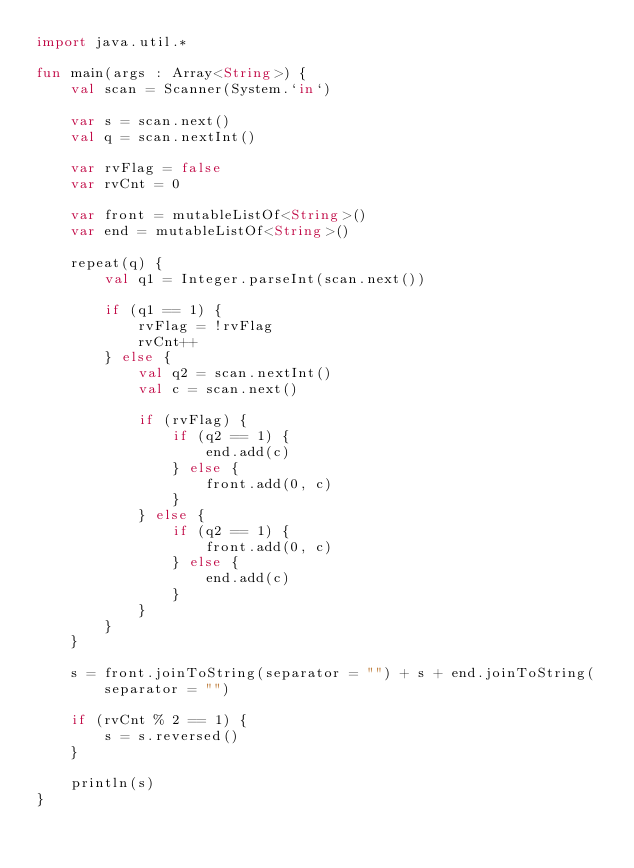<code> <loc_0><loc_0><loc_500><loc_500><_Kotlin_>import java.util.*

fun main(args : Array<String>) {
    val scan = Scanner(System.`in`)

    var s = scan.next()
    val q = scan.nextInt()

    var rvFlag = false
    var rvCnt = 0

    var front = mutableListOf<String>()
    var end = mutableListOf<String>()

    repeat(q) {
        val q1 = Integer.parseInt(scan.next())

        if (q1 == 1) {
            rvFlag = !rvFlag
            rvCnt++
        } else {
            val q2 = scan.nextInt()
            val c = scan.next()

            if (rvFlag) {
                if (q2 == 1) {
                    end.add(c)
                } else {
                    front.add(0, c)
                }
            } else {
                if (q2 == 1) {
                    front.add(0, c)
                } else {
                    end.add(c)
                }
            }
        }
    }

    s = front.joinToString(separator = "") + s + end.joinToString(separator = "")

    if (rvCnt % 2 == 1) {
        s = s.reversed()
    }

    println(s)
}</code> 